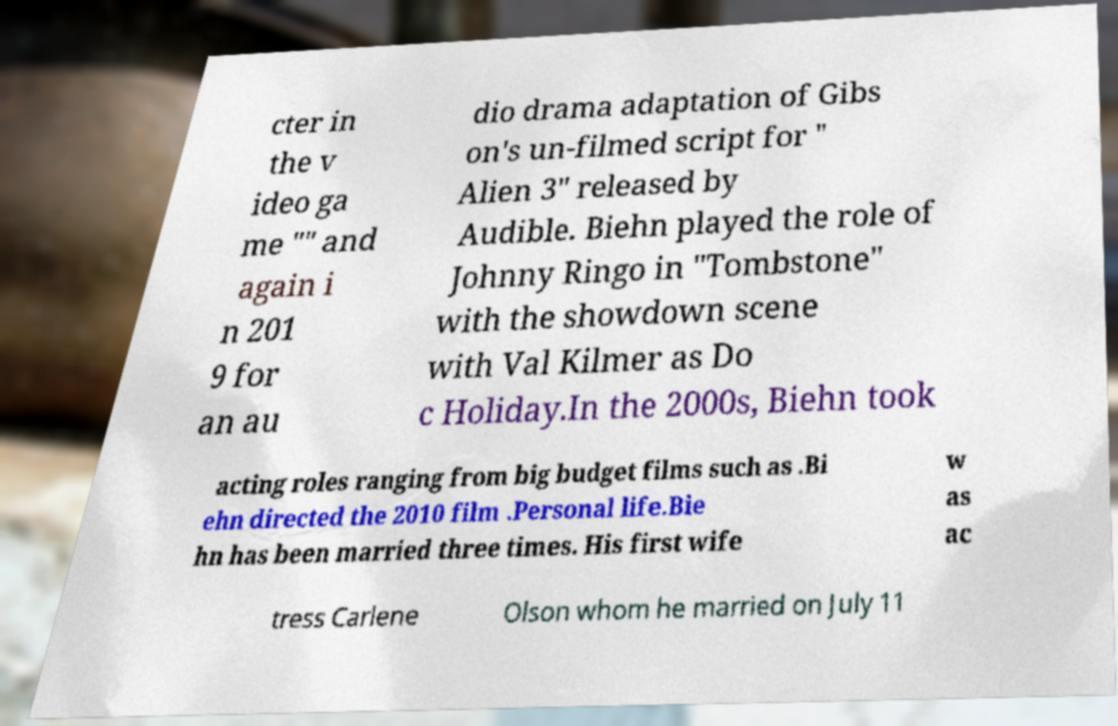Can you read and provide the text displayed in the image?This photo seems to have some interesting text. Can you extract and type it out for me? cter in the v ideo ga me "" and again i n 201 9 for an au dio drama adaptation of Gibs on's un-filmed script for " Alien 3" released by Audible. Biehn played the role of Johnny Ringo in "Tombstone" with the showdown scene with Val Kilmer as Do c Holiday.In the 2000s, Biehn took acting roles ranging from big budget films such as .Bi ehn directed the 2010 film .Personal life.Bie hn has been married three times. His first wife w as ac tress Carlene Olson whom he married on July 11 